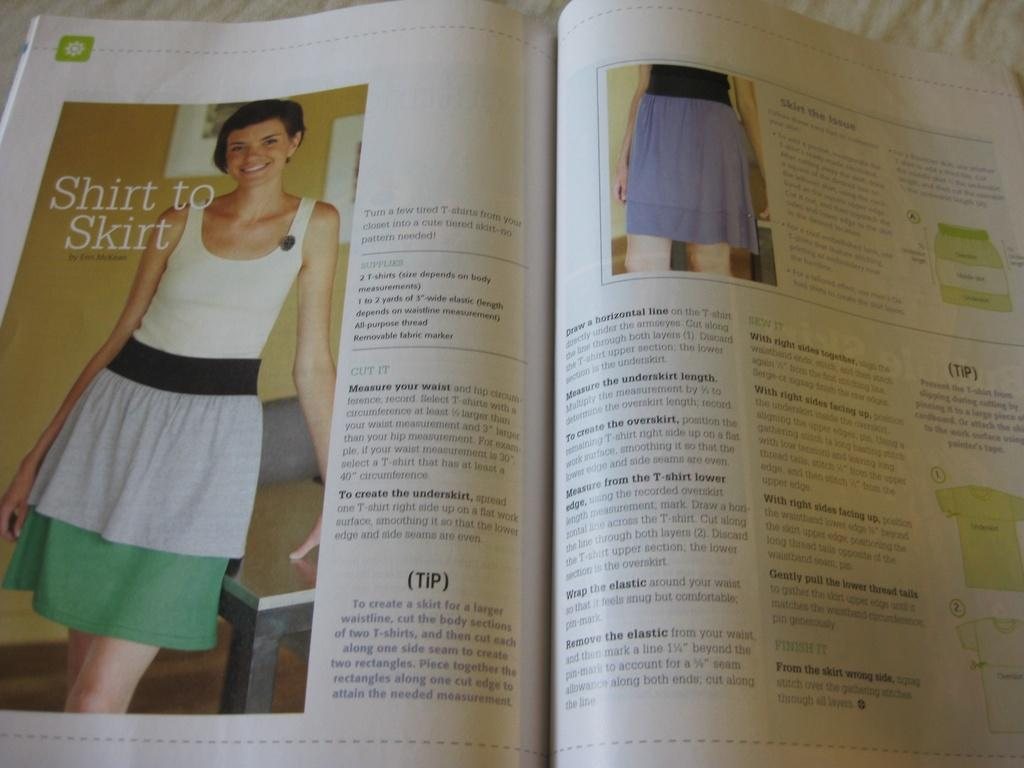<image>
Summarize the visual content of the image. A book is open to a page with a picture that reads Shirt to Skirt. 